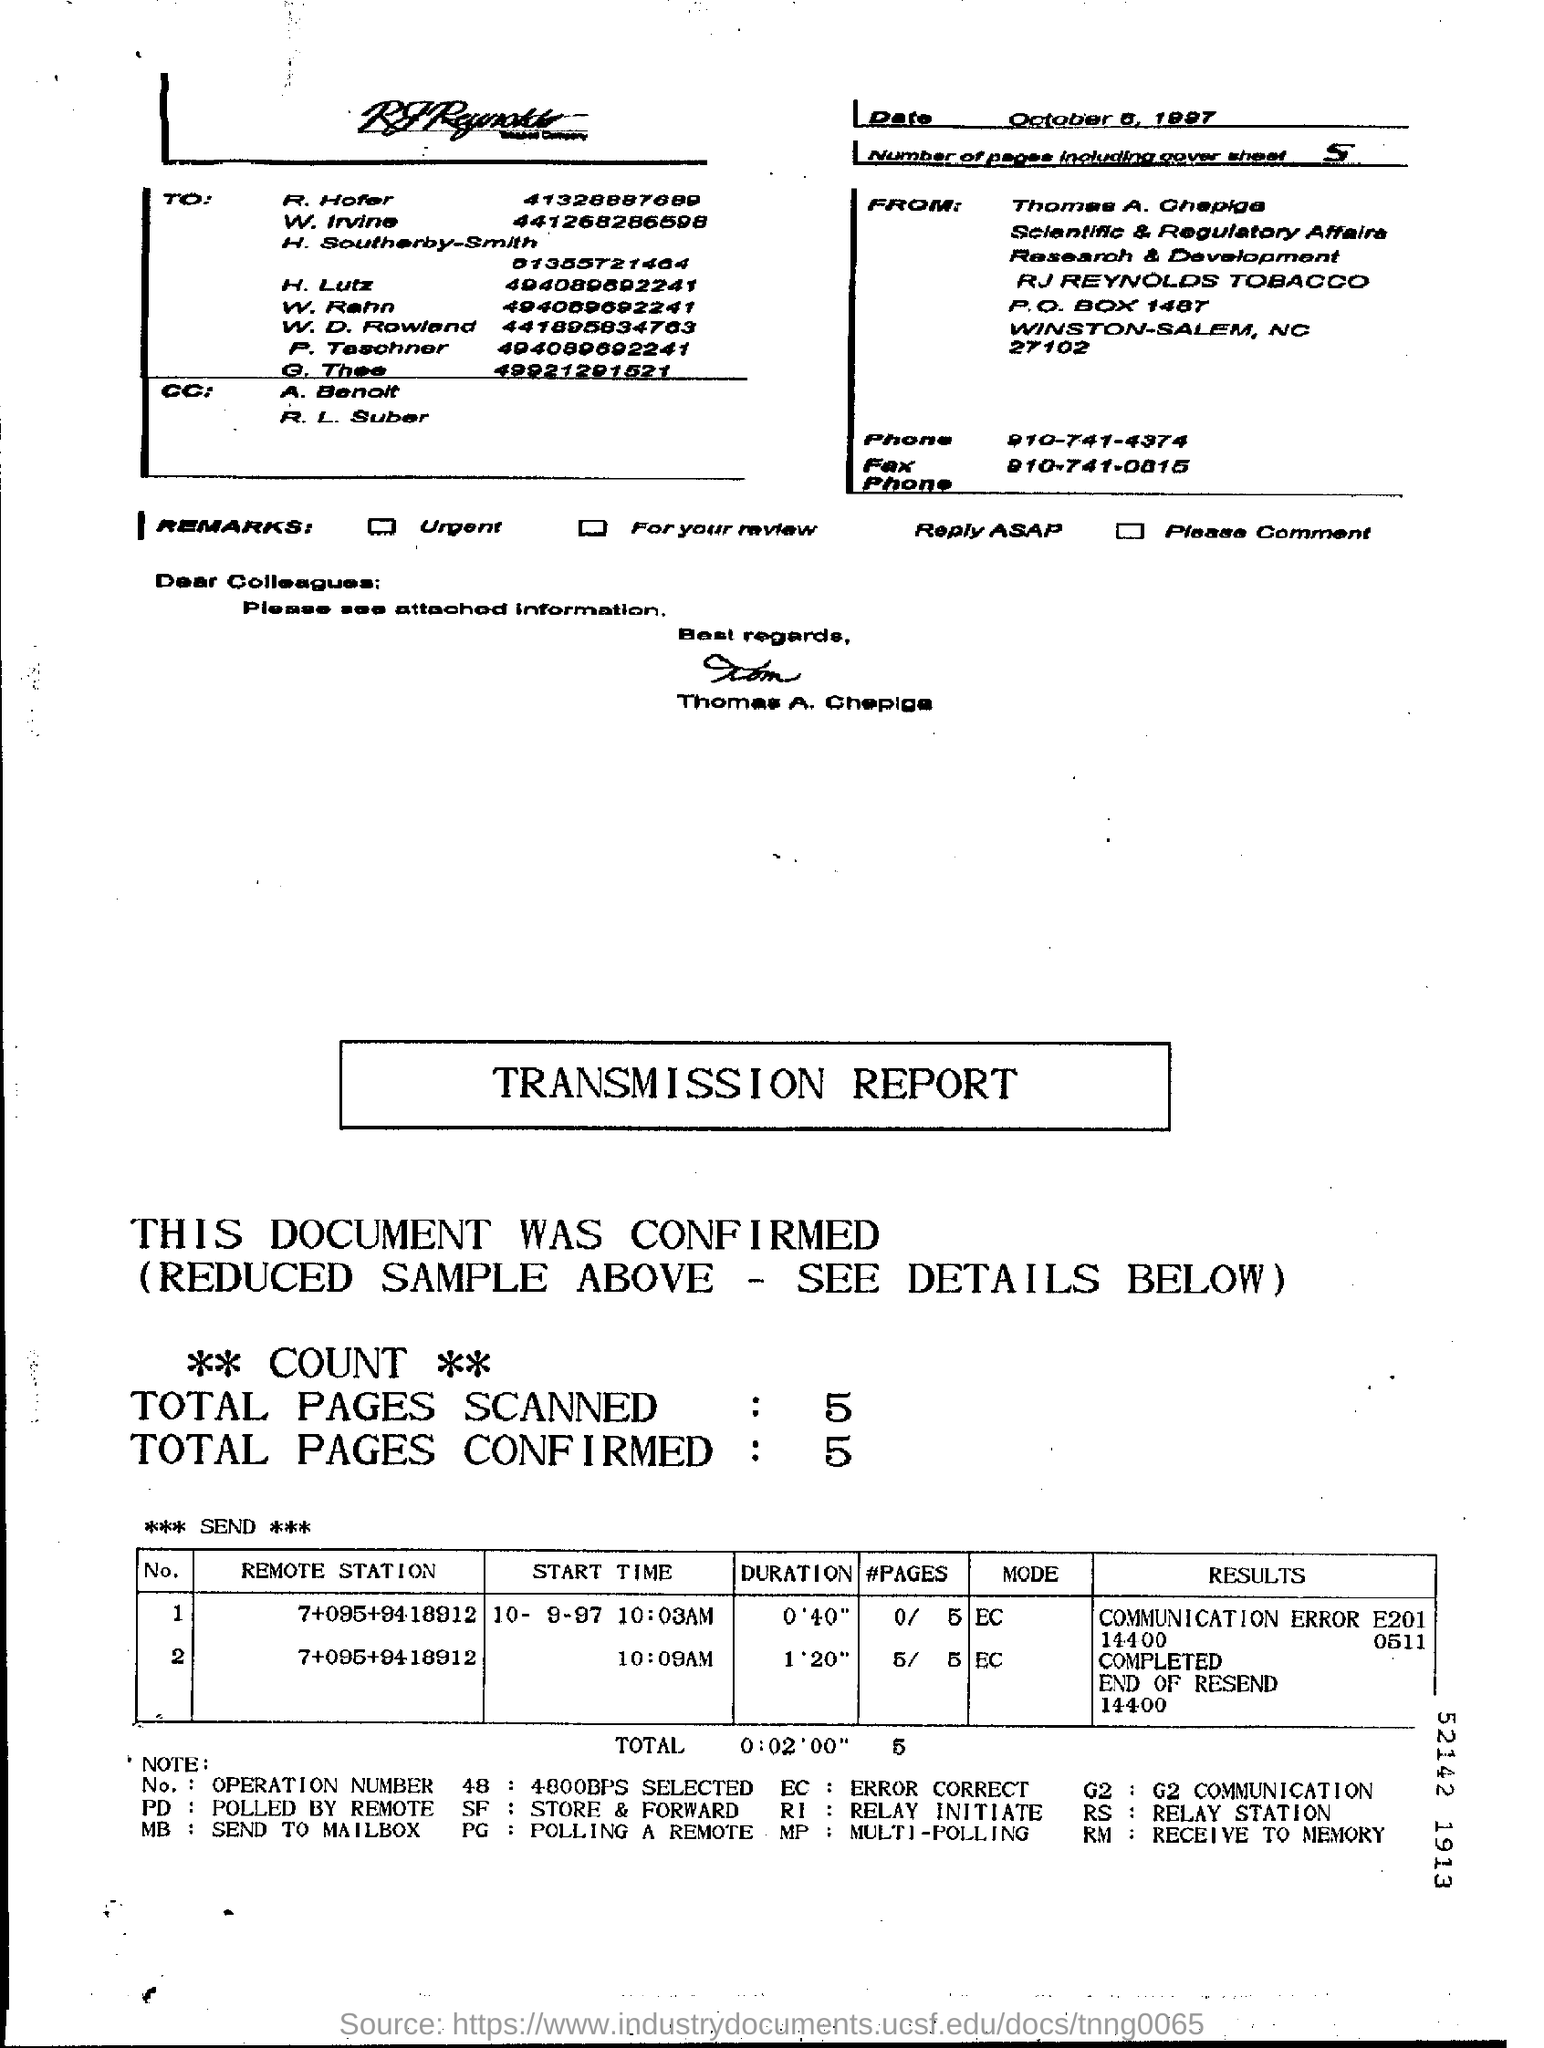Highlight a few significant elements in this photo. The transmission report indicates that a total of 5 pages have been scanned. The transmission report states that the total duration of the transmission is 2 minutes and 0 seconds. The person who signed the fax document is Thomas A. Chepiga. There are five pages in the fax, including the cover sheet. 